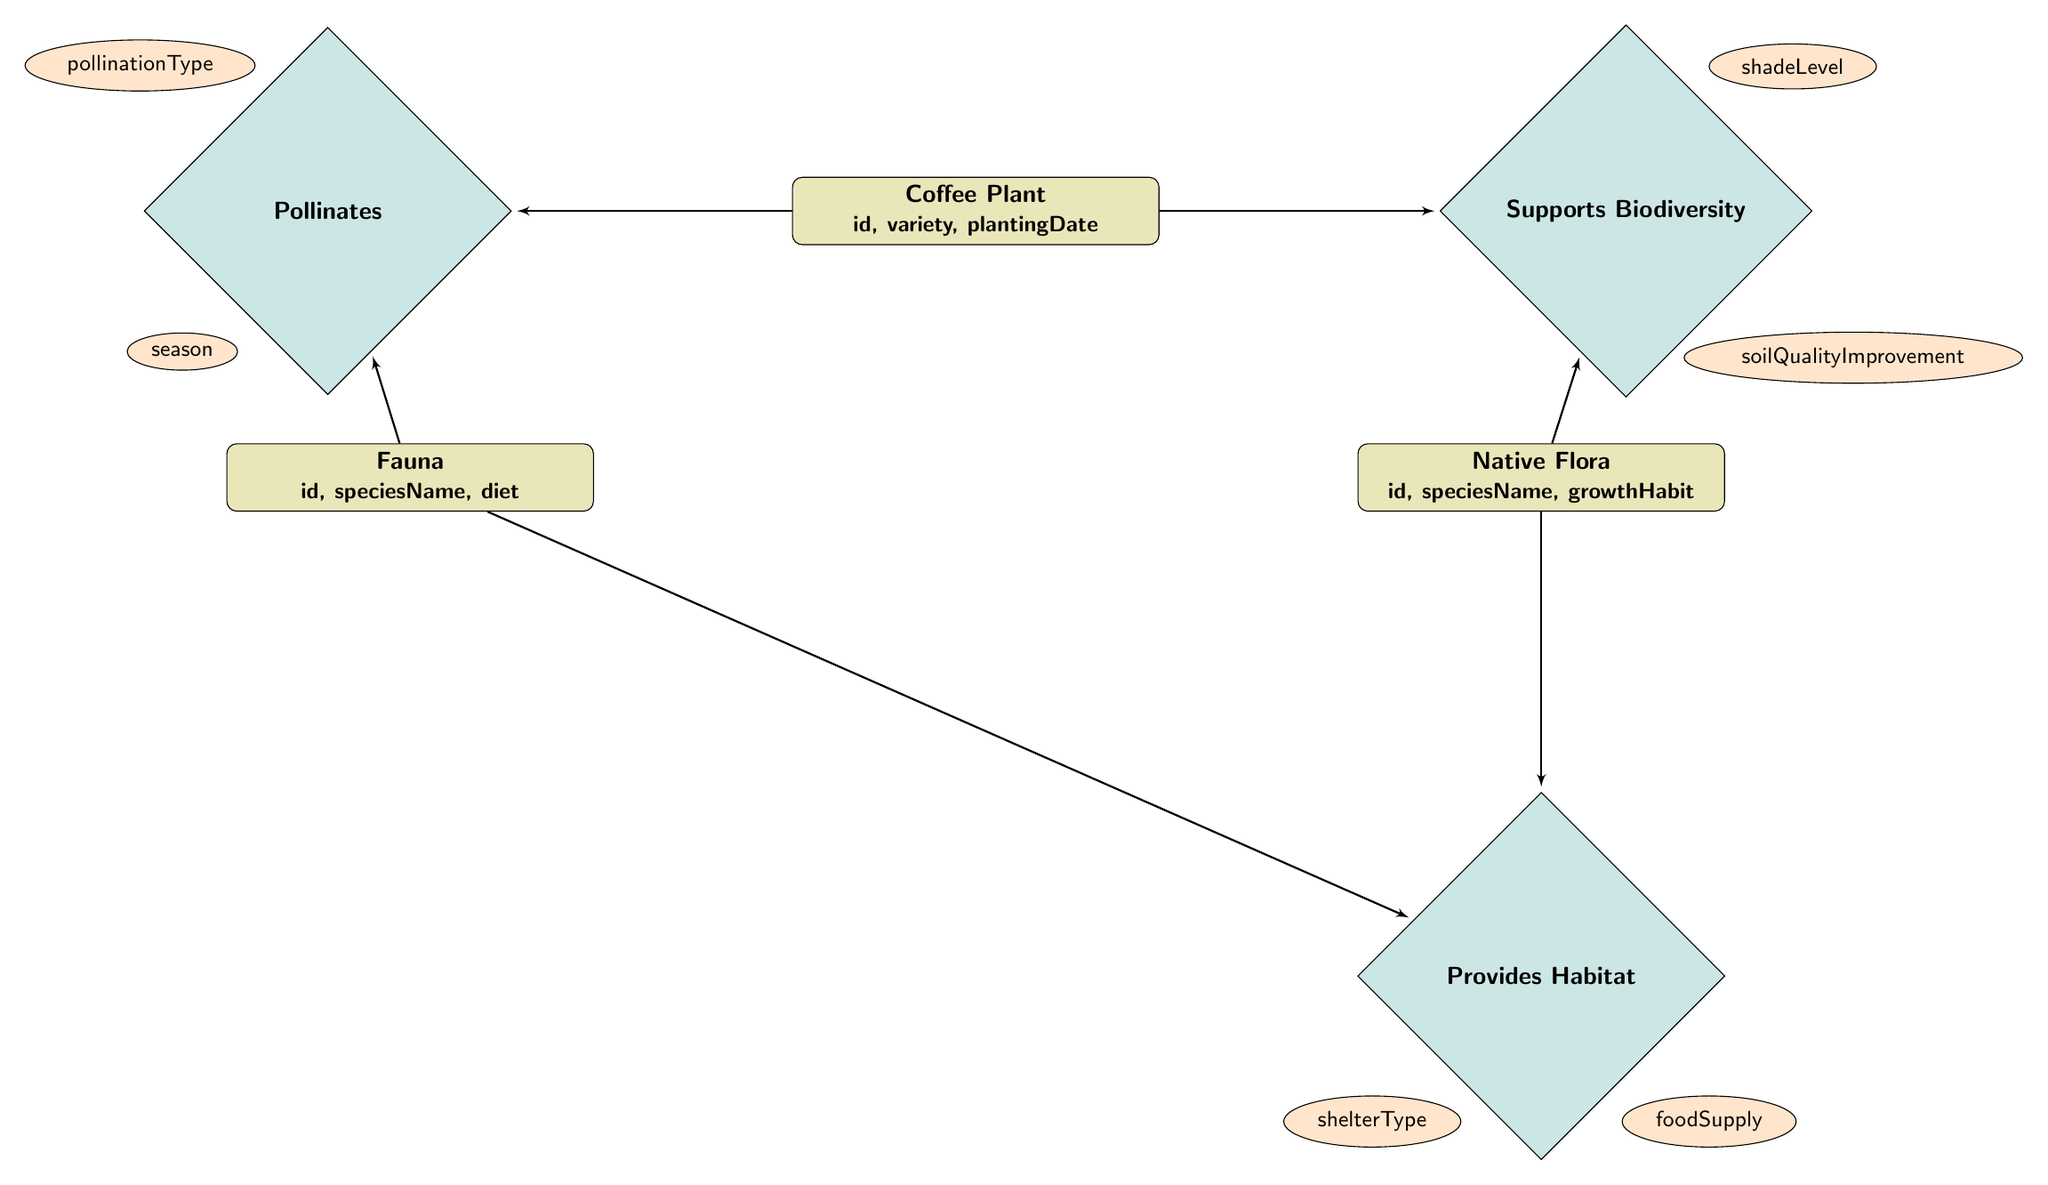What are the attributes of the Coffee Plant entity? The attributes of the Coffee Plant entity are listed as "id," "variety," and "plantingDate". This information can be found directly in the node representing the Coffee Plant.
Answer: id, variety, plantingDate How many relationships does the Native Flora entity have? The Native Flora entity has two relationships depicted in the diagram: it supports biodiversity with the Coffee Plant and provides habitat for the Fauna. Therefore, counting these relationships gives us a total of two.
Answer: 2 What is the relationship between Fauna and Coffee Plant? The relationship between Fauna and Coffee Plant is labeled as "Pollinates". This can be seen directly connecting these two entities in the diagram.
Answer: Pollinates What attributes are associated with the relationship that supports biodiversity? The attributes associated with the "Supports Biodiversity" relationship are "shadeLevel" and "soilQualityImprovement". This is indicated by the dashed lines connecting these attributes to the relationship in the diagram.
Answer: shadeLevel, soilQualityImprovement Which entity provides food supply for Fauna? The Native Flora entity provides food supply for Fauna, as indicated by the relationship "Provides Habitat" that connects Native Flora to Fauna. This relationship also includes the attribute "foodSupply".
Answer: Native Flora What type of relationship exists between Native Flora and Fauna? The type of relationship between Native Flora and Fauna is "Provides Habitat". This can be directly observed connecting the respective entities in the diagram.
Answer: Provides Habitat How many attributes does the "Pollinates" relationship have? The "Pollinates" relationship has two attributes: "pollinationType" and "season". These attributes are listed in the diagram next to their relationship.
Answer: 2 What is the growth habit of Native Flora denoted by? The growth habit of Native Flora is denoted by the attribute "growthHabit", which is included in the attributes of the Native Flora entity in the diagram.
Answer: growthHabit How does the Coffee Plant interact with Native Flora? The Coffee Plant interacts with Native Flora through the "Supports Biodiversity" relationship, which indicates that Coffee Plants support Native Flora in terms of shade level and soil quality improvement.
Answer: Supports Biodiversity 